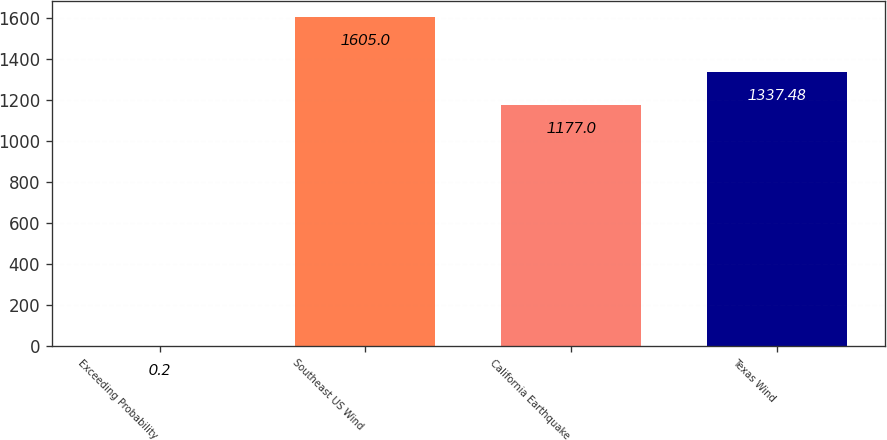<chart> <loc_0><loc_0><loc_500><loc_500><bar_chart><fcel>Exceeding Probability<fcel>Southeast US Wind<fcel>California Earthquake<fcel>Texas Wind<nl><fcel>0.2<fcel>1605<fcel>1177<fcel>1337.48<nl></chart> 